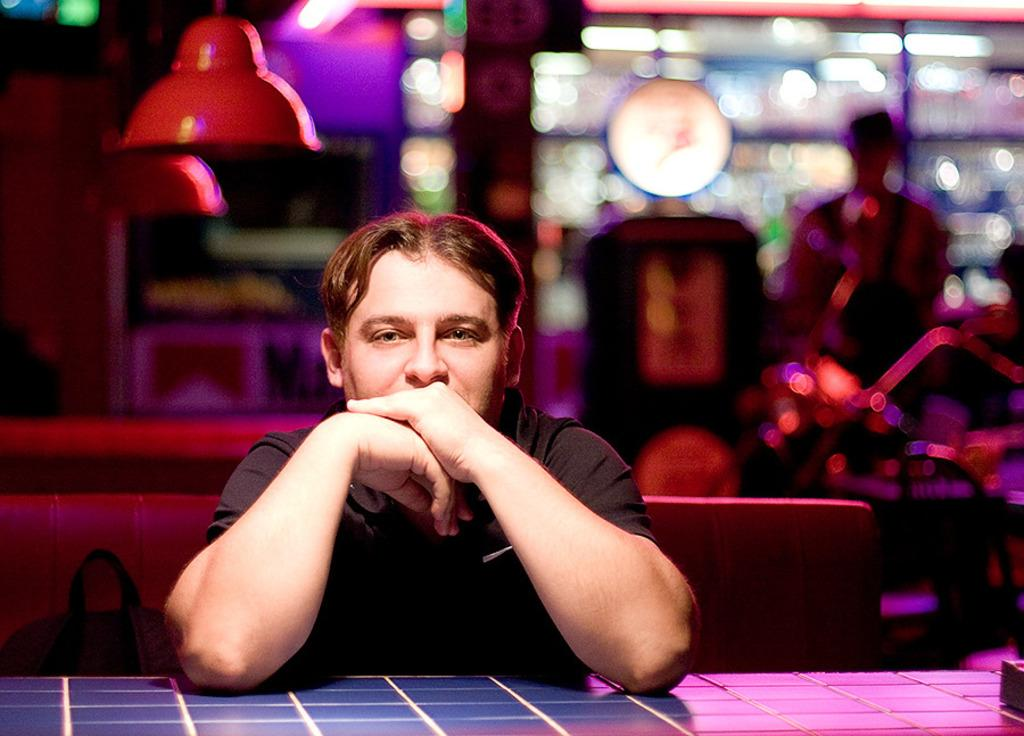What is the person in the image doing? There is a person sitting in the image. What is the person wearing? The person is wearing a black dress. What can be seen in the image besides the person? There are lights visible in the image. How would you describe the background of the image? The background of the image is blurred. What type of twig is the person holding in the image? There is no twig present in the image; the person is sitting and wearing a black dress. 